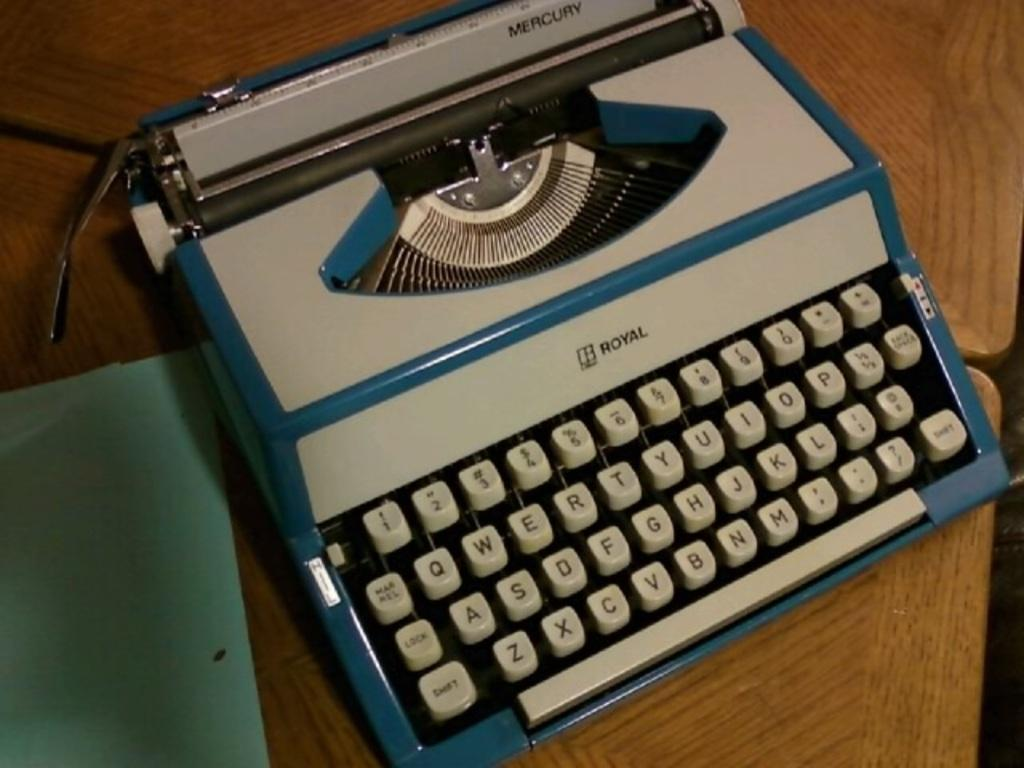Provide a one-sentence caption for the provided image. An old white and blue typewriter from the manufacturer Royal. 